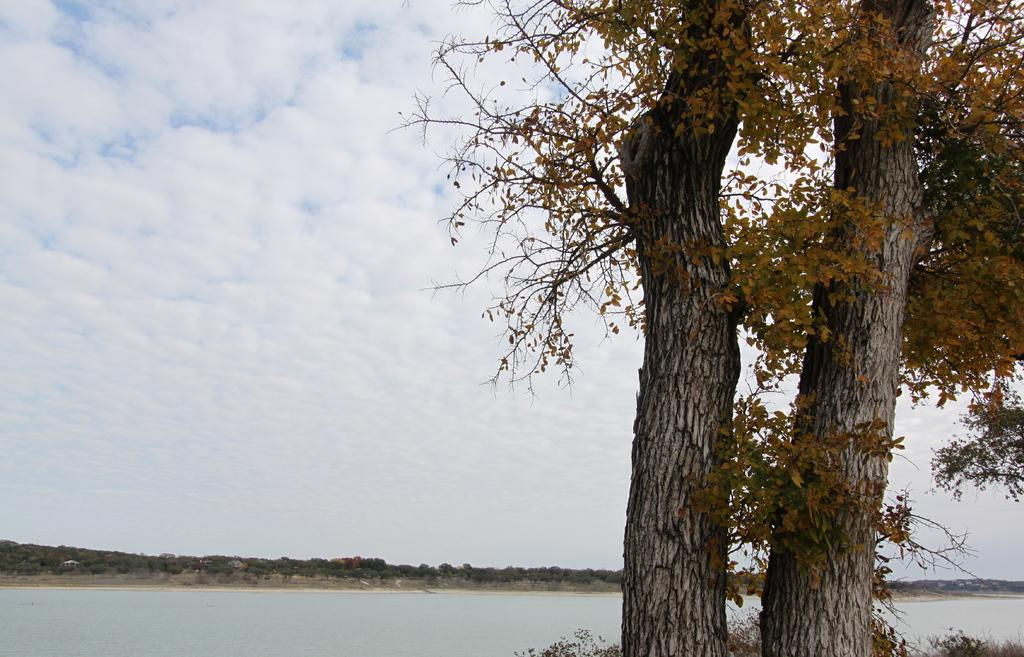What type of vegetation is on the right side of the image? There are trees on the right side of the image. What is located in the center of the image? There is a water body in the center of the image. What can be seen in the background of the image? There are trees in the background of the image. How would you describe the sky in the image? The sky is cloudy. Where is the fork located in the image? There is no fork present in the image. Can you see a toad near the water body in the image? There is no toad present in the image. 